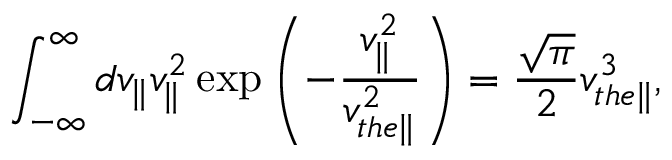<formula> <loc_0><loc_0><loc_500><loc_500>\int _ { - \infty } ^ { \infty } d v _ { \| } v _ { \| } ^ { 2 } \exp \left ( - \frac { v _ { \| } ^ { 2 } } { v _ { t h e \| } ^ { 2 } } \right ) = \frac { \sqrt { \pi } } { 2 } v _ { t h e \| } ^ { 3 } ,</formula> 